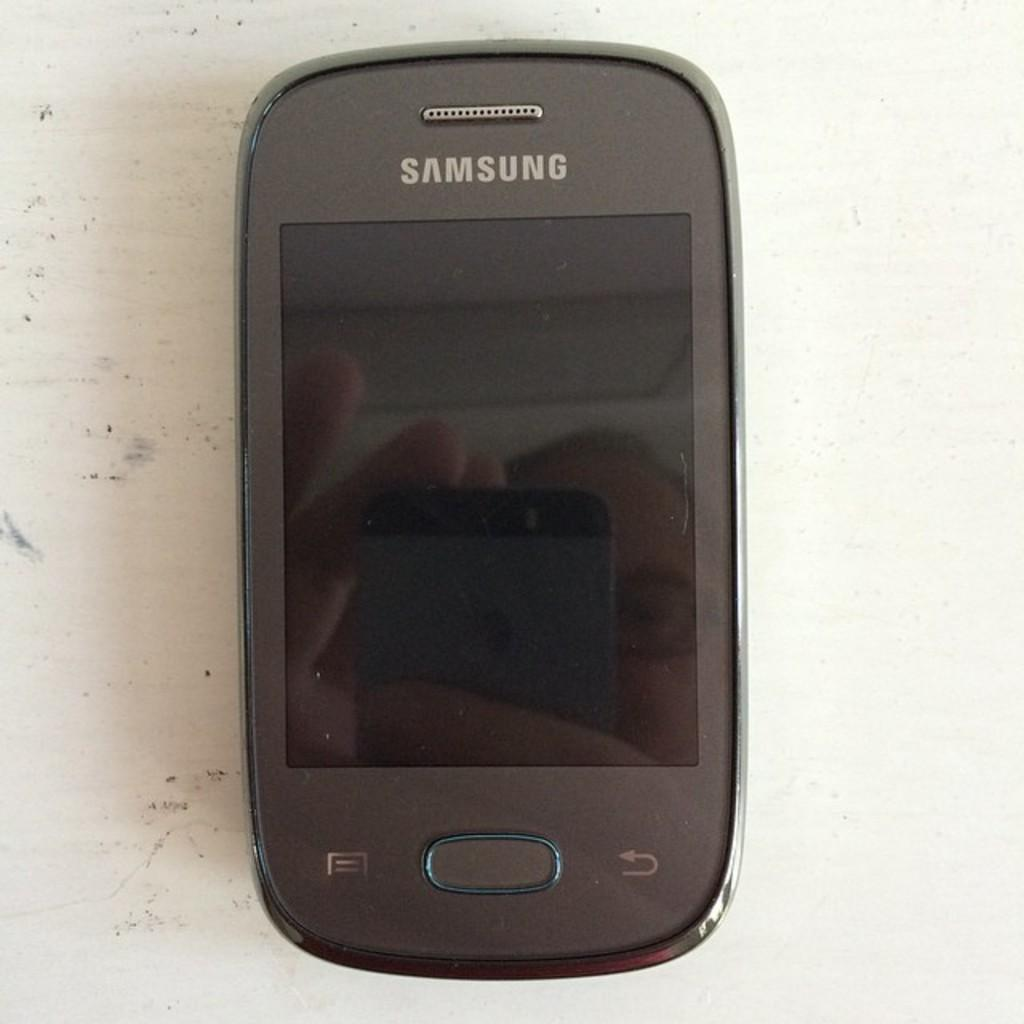<image>
Share a concise interpretation of the image provided. A person is reflected in the screen while they are using their Samsung cell phone. 